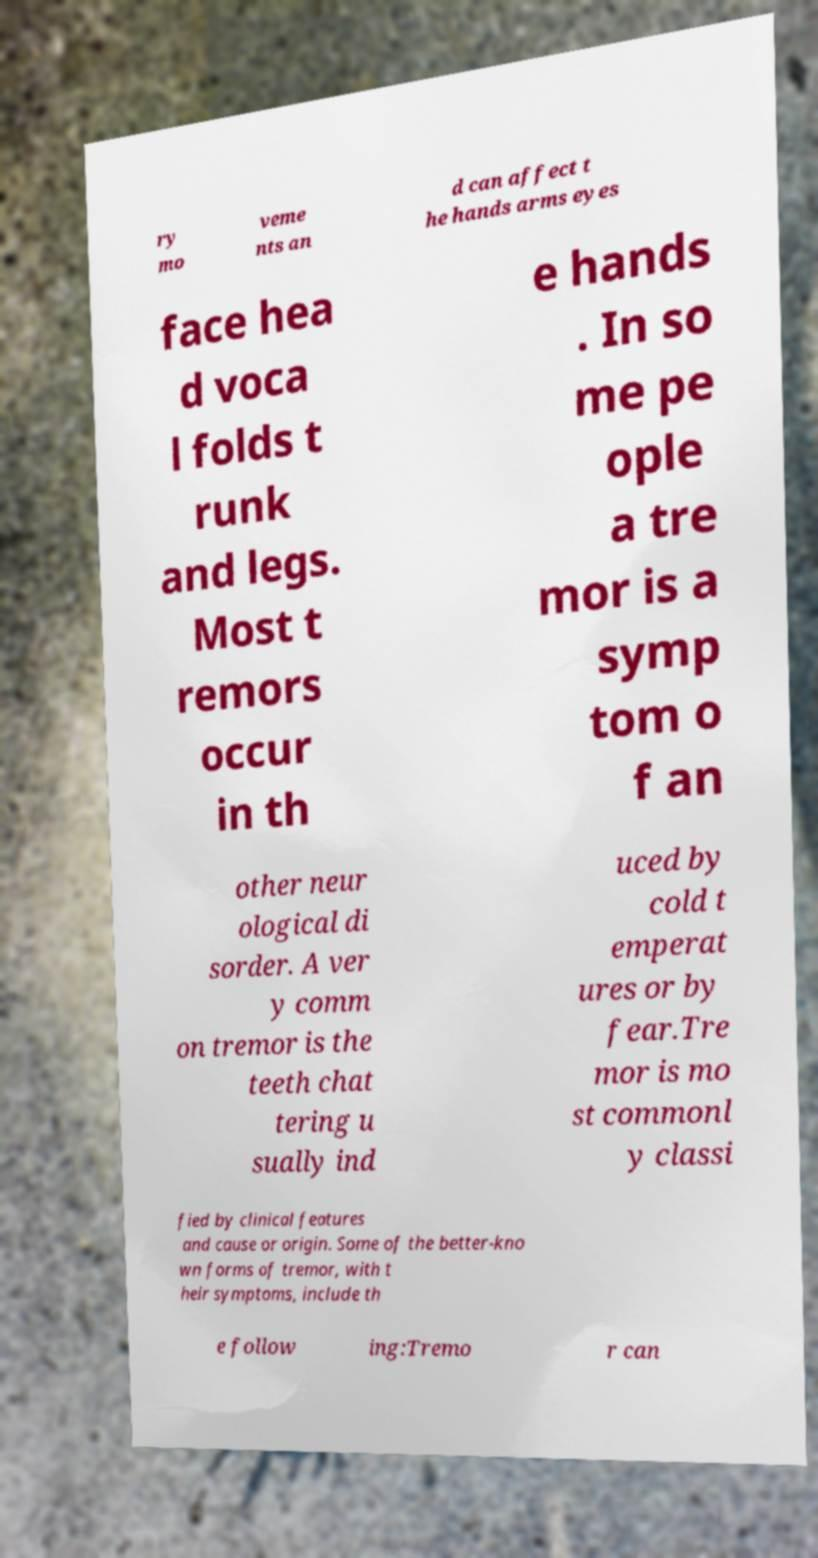Can you read and provide the text displayed in the image?This photo seems to have some interesting text. Can you extract and type it out for me? ry mo veme nts an d can affect t he hands arms eyes face hea d voca l folds t runk and legs. Most t remors occur in th e hands . In so me pe ople a tre mor is a symp tom o f an other neur ological di sorder. A ver y comm on tremor is the teeth chat tering u sually ind uced by cold t emperat ures or by fear.Tre mor is mo st commonl y classi fied by clinical features and cause or origin. Some of the better-kno wn forms of tremor, with t heir symptoms, include th e follow ing:Tremo r can 